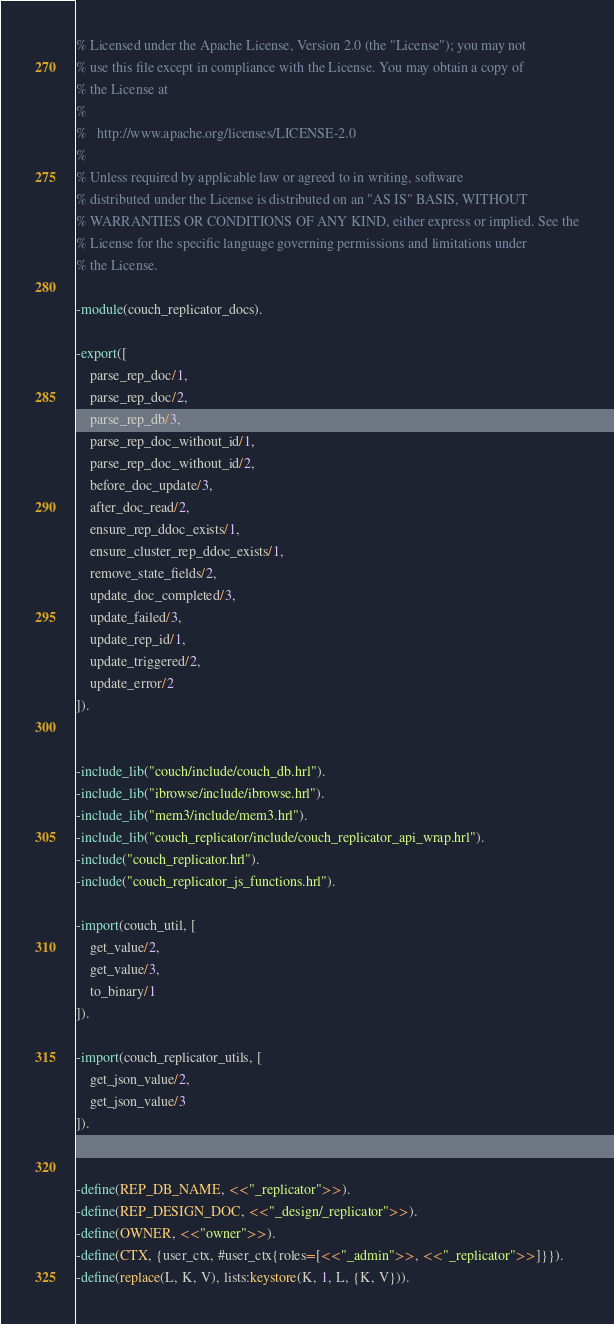Convert code to text. <code><loc_0><loc_0><loc_500><loc_500><_Erlang_>% Licensed under the Apache License, Version 2.0 (the "License"); you may not
% use this file except in compliance with the License. You may obtain a copy of
% the License at
%
%   http://www.apache.org/licenses/LICENSE-2.0
%
% Unless required by applicable law or agreed to in writing, software
% distributed under the License is distributed on an "AS IS" BASIS, WITHOUT
% WARRANTIES OR CONDITIONS OF ANY KIND, either express or implied. See the
% License for the specific language governing permissions and limitations under
% the License.

-module(couch_replicator_docs).

-export([
    parse_rep_doc/1,
    parse_rep_doc/2,
    parse_rep_db/3,
    parse_rep_doc_without_id/1,
    parse_rep_doc_without_id/2,
    before_doc_update/3,
    after_doc_read/2,
    ensure_rep_ddoc_exists/1,
    ensure_cluster_rep_ddoc_exists/1,
    remove_state_fields/2,
    update_doc_completed/3,
    update_failed/3,
    update_rep_id/1,
    update_triggered/2,
    update_error/2
]).


-include_lib("couch/include/couch_db.hrl").
-include_lib("ibrowse/include/ibrowse.hrl").
-include_lib("mem3/include/mem3.hrl").
-include_lib("couch_replicator/include/couch_replicator_api_wrap.hrl").
-include("couch_replicator.hrl").
-include("couch_replicator_js_functions.hrl").

-import(couch_util, [
    get_value/2,
    get_value/3,
    to_binary/1
]).

-import(couch_replicator_utils, [
    get_json_value/2,
    get_json_value/3
]).


-define(REP_DB_NAME, <<"_replicator">>).
-define(REP_DESIGN_DOC, <<"_design/_replicator">>).
-define(OWNER, <<"owner">>).
-define(CTX, {user_ctx, #user_ctx{roles=[<<"_admin">>, <<"_replicator">>]}}).
-define(replace(L, K, V), lists:keystore(K, 1, L, {K, V})).

</code> 